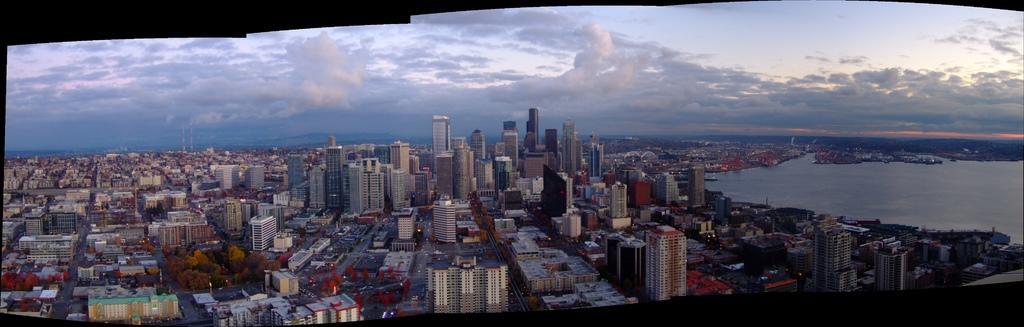Can you describe this image briefly? In this image, we can see so many buildings, houses, trees, roads, water. Top of the image, there is a cloudy sky. 